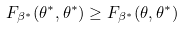Convert formula to latex. <formula><loc_0><loc_0><loc_500><loc_500>F _ { \beta ^ { * } } ( \theta ^ { * } , \theta ^ { * } ) \geq F _ { \beta ^ { * } } ( \theta , \theta ^ { * } )</formula> 